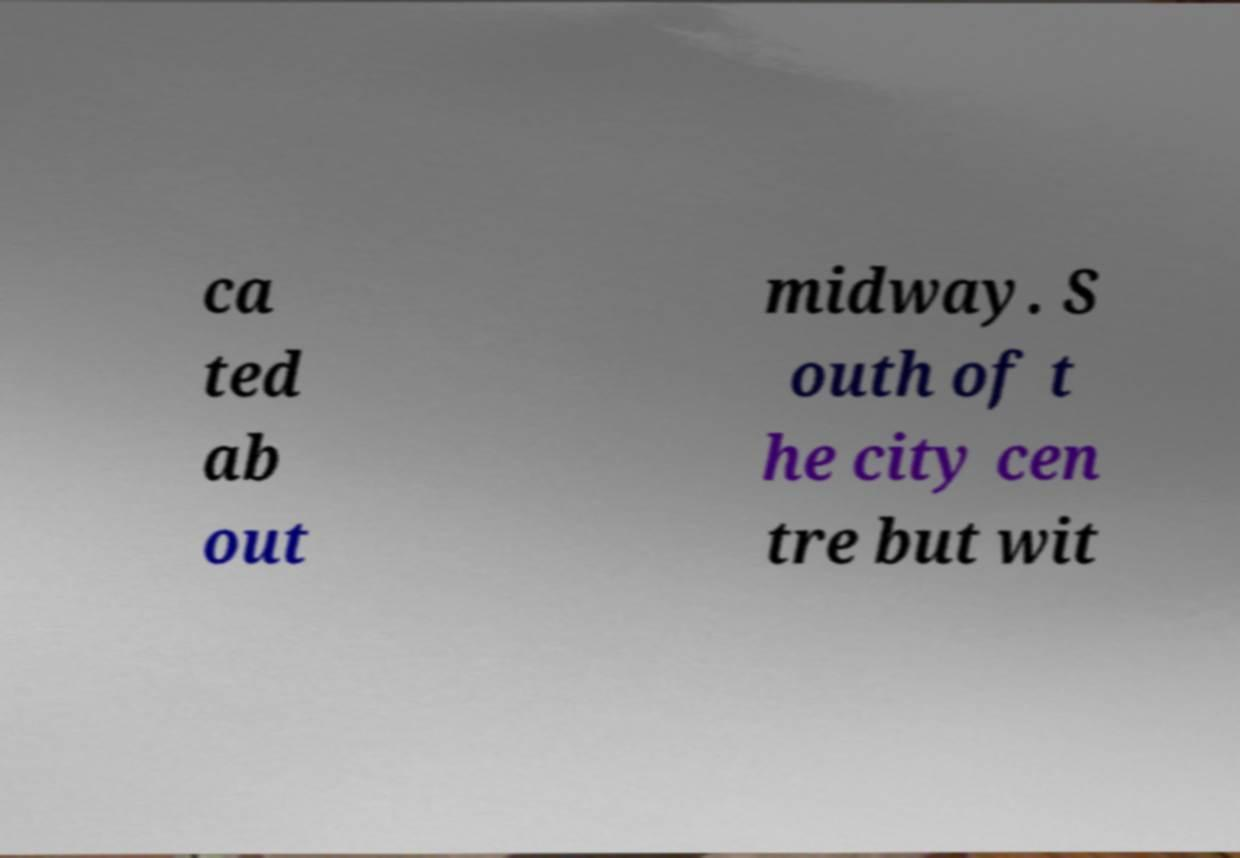For documentation purposes, I need the text within this image transcribed. Could you provide that? ca ted ab out midway. S outh of t he city cen tre but wit 